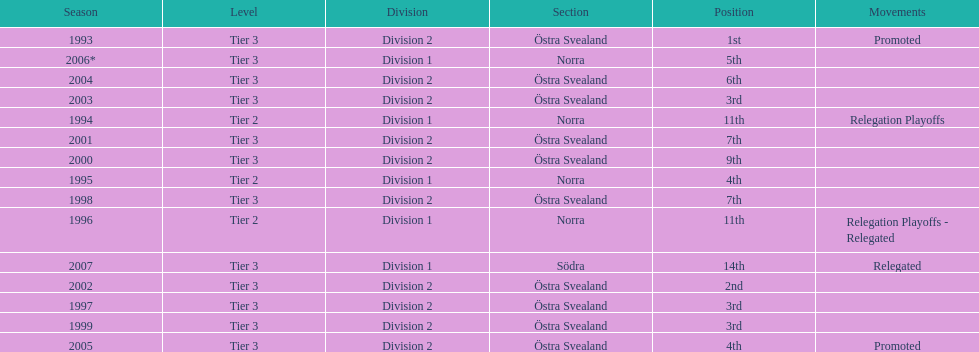They ranked third in 200 1999. 